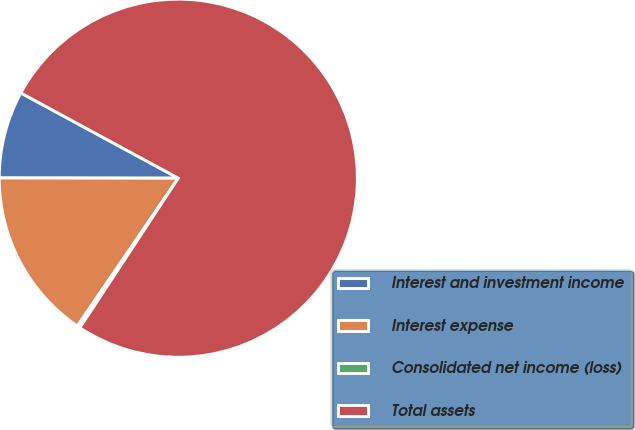<chart> <loc_0><loc_0><loc_500><loc_500><pie_chart><fcel>Interest and investment income<fcel>Interest expense<fcel>Consolidated net income (loss)<fcel>Total assets<nl><fcel>7.88%<fcel>15.49%<fcel>0.27%<fcel>76.37%<nl></chart> 